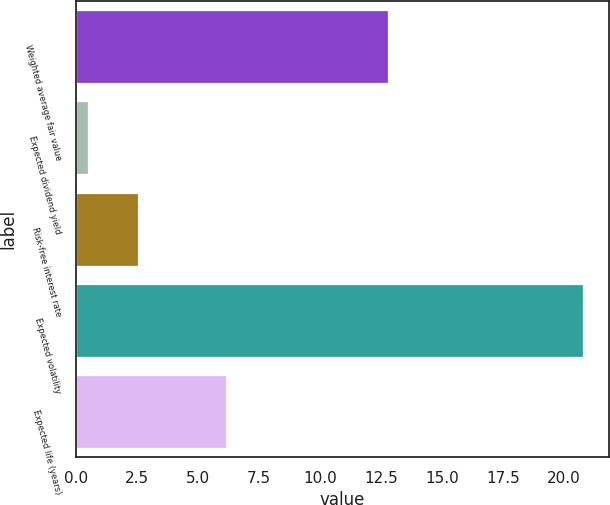<chart> <loc_0><loc_0><loc_500><loc_500><bar_chart><fcel>Weighted average fair value<fcel>Expected dividend yield<fcel>Risk-free interest rate<fcel>Expected volatility<fcel>Expected life (years)<nl><fcel>12.78<fcel>0.52<fcel>2.55<fcel>20.8<fcel>6.14<nl></chart> 